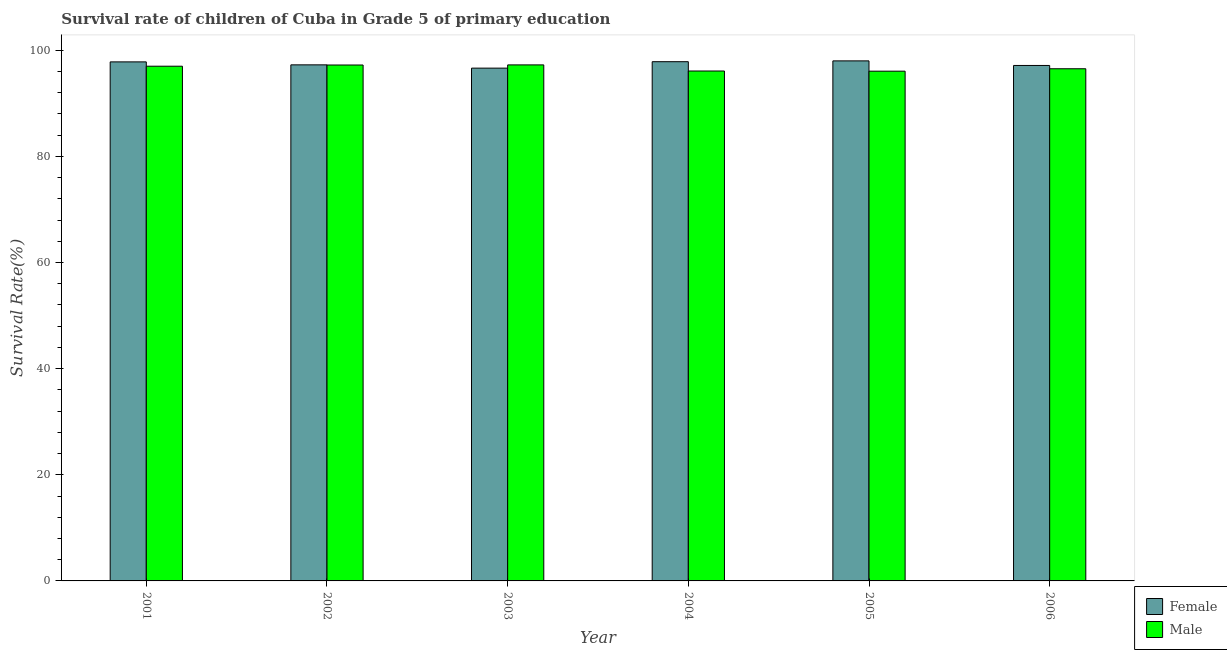How many different coloured bars are there?
Give a very brief answer. 2. Are the number of bars on each tick of the X-axis equal?
Provide a short and direct response. Yes. How many bars are there on the 2nd tick from the left?
Keep it short and to the point. 2. How many bars are there on the 1st tick from the right?
Ensure brevity in your answer.  2. What is the label of the 6th group of bars from the left?
Provide a short and direct response. 2006. In how many cases, is the number of bars for a given year not equal to the number of legend labels?
Your answer should be compact. 0. What is the survival rate of male students in primary education in 2004?
Your answer should be compact. 96.09. Across all years, what is the maximum survival rate of female students in primary education?
Give a very brief answer. 98. Across all years, what is the minimum survival rate of female students in primary education?
Make the answer very short. 96.63. In which year was the survival rate of female students in primary education maximum?
Your response must be concise. 2005. What is the total survival rate of male students in primary education in the graph?
Ensure brevity in your answer.  580.12. What is the difference between the survival rate of female students in primary education in 2001 and that in 2002?
Ensure brevity in your answer.  0.56. What is the difference between the survival rate of female students in primary education in 2001 and the survival rate of male students in primary education in 2006?
Provide a short and direct response. 0.67. What is the average survival rate of male students in primary education per year?
Provide a succinct answer. 96.69. In the year 2003, what is the difference between the survival rate of female students in primary education and survival rate of male students in primary education?
Your response must be concise. 0. In how many years, is the survival rate of male students in primary education greater than 4 %?
Provide a succinct answer. 6. What is the ratio of the survival rate of female students in primary education in 2001 to that in 2003?
Keep it short and to the point. 1.01. Is the survival rate of male students in primary education in 2001 less than that in 2002?
Your response must be concise. Yes. Is the difference between the survival rate of male students in primary education in 2001 and 2006 greater than the difference between the survival rate of female students in primary education in 2001 and 2006?
Provide a succinct answer. No. What is the difference between the highest and the second highest survival rate of female students in primary education?
Your answer should be compact. 0.15. What is the difference between the highest and the lowest survival rate of female students in primary education?
Provide a succinct answer. 1.37. What does the 2nd bar from the right in 2005 represents?
Your answer should be very brief. Female. How many bars are there?
Give a very brief answer. 12. How many years are there in the graph?
Your answer should be very brief. 6. What is the difference between two consecutive major ticks on the Y-axis?
Offer a terse response. 20. Does the graph contain grids?
Provide a succinct answer. No. How are the legend labels stacked?
Your answer should be very brief. Vertical. What is the title of the graph?
Your response must be concise. Survival rate of children of Cuba in Grade 5 of primary education. Does "Under five" appear as one of the legend labels in the graph?
Give a very brief answer. No. What is the label or title of the Y-axis?
Give a very brief answer. Survival Rate(%). What is the Survival Rate(%) of Female in 2001?
Provide a succinct answer. 97.81. What is the Survival Rate(%) of Male in 2001?
Provide a short and direct response. 96.99. What is the Survival Rate(%) of Female in 2002?
Ensure brevity in your answer.  97.25. What is the Survival Rate(%) in Male in 2002?
Your response must be concise. 97.22. What is the Survival Rate(%) in Female in 2003?
Offer a very short reply. 96.63. What is the Survival Rate(%) of Male in 2003?
Your response must be concise. 97.24. What is the Survival Rate(%) in Female in 2004?
Your answer should be compact. 97.84. What is the Survival Rate(%) of Male in 2004?
Give a very brief answer. 96.09. What is the Survival Rate(%) in Female in 2005?
Provide a short and direct response. 98. What is the Survival Rate(%) of Male in 2005?
Offer a very short reply. 96.06. What is the Survival Rate(%) of Female in 2006?
Provide a short and direct response. 97.14. What is the Survival Rate(%) in Male in 2006?
Your answer should be very brief. 96.51. Across all years, what is the maximum Survival Rate(%) in Female?
Keep it short and to the point. 98. Across all years, what is the maximum Survival Rate(%) in Male?
Offer a terse response. 97.24. Across all years, what is the minimum Survival Rate(%) of Female?
Offer a terse response. 96.63. Across all years, what is the minimum Survival Rate(%) in Male?
Your answer should be very brief. 96.06. What is the total Survival Rate(%) in Female in the graph?
Your response must be concise. 584.67. What is the total Survival Rate(%) of Male in the graph?
Ensure brevity in your answer.  580.12. What is the difference between the Survival Rate(%) of Female in 2001 and that in 2002?
Give a very brief answer. 0.56. What is the difference between the Survival Rate(%) in Male in 2001 and that in 2002?
Your response must be concise. -0.23. What is the difference between the Survival Rate(%) in Female in 2001 and that in 2003?
Provide a short and direct response. 1.18. What is the difference between the Survival Rate(%) in Male in 2001 and that in 2003?
Offer a terse response. -0.25. What is the difference between the Survival Rate(%) of Female in 2001 and that in 2004?
Ensure brevity in your answer.  -0.04. What is the difference between the Survival Rate(%) of Male in 2001 and that in 2004?
Offer a very short reply. 0.9. What is the difference between the Survival Rate(%) of Female in 2001 and that in 2005?
Make the answer very short. -0.19. What is the difference between the Survival Rate(%) of Male in 2001 and that in 2005?
Offer a terse response. 0.94. What is the difference between the Survival Rate(%) of Female in 2001 and that in 2006?
Provide a succinct answer. 0.67. What is the difference between the Survival Rate(%) in Male in 2001 and that in 2006?
Your response must be concise. 0.48. What is the difference between the Survival Rate(%) of Female in 2002 and that in 2003?
Keep it short and to the point. 0.62. What is the difference between the Survival Rate(%) of Male in 2002 and that in 2003?
Offer a terse response. -0.02. What is the difference between the Survival Rate(%) in Female in 2002 and that in 2004?
Your answer should be very brief. -0.6. What is the difference between the Survival Rate(%) of Male in 2002 and that in 2004?
Provide a succinct answer. 1.13. What is the difference between the Survival Rate(%) of Female in 2002 and that in 2005?
Make the answer very short. -0.75. What is the difference between the Survival Rate(%) of Male in 2002 and that in 2005?
Offer a terse response. 1.16. What is the difference between the Survival Rate(%) of Female in 2002 and that in 2006?
Make the answer very short. 0.11. What is the difference between the Survival Rate(%) in Male in 2002 and that in 2006?
Your answer should be very brief. 0.71. What is the difference between the Survival Rate(%) in Female in 2003 and that in 2004?
Make the answer very short. -1.21. What is the difference between the Survival Rate(%) of Male in 2003 and that in 2004?
Offer a terse response. 1.15. What is the difference between the Survival Rate(%) of Female in 2003 and that in 2005?
Make the answer very short. -1.37. What is the difference between the Survival Rate(%) in Male in 2003 and that in 2005?
Provide a short and direct response. 1.18. What is the difference between the Survival Rate(%) in Female in 2003 and that in 2006?
Give a very brief answer. -0.5. What is the difference between the Survival Rate(%) in Male in 2003 and that in 2006?
Your answer should be compact. 0.73. What is the difference between the Survival Rate(%) of Female in 2004 and that in 2005?
Make the answer very short. -0.15. What is the difference between the Survival Rate(%) of Male in 2004 and that in 2005?
Your response must be concise. 0.03. What is the difference between the Survival Rate(%) in Female in 2004 and that in 2006?
Keep it short and to the point. 0.71. What is the difference between the Survival Rate(%) in Male in 2004 and that in 2006?
Your answer should be very brief. -0.42. What is the difference between the Survival Rate(%) of Female in 2005 and that in 2006?
Your response must be concise. 0.86. What is the difference between the Survival Rate(%) of Male in 2005 and that in 2006?
Your answer should be very brief. -0.46. What is the difference between the Survival Rate(%) in Female in 2001 and the Survival Rate(%) in Male in 2002?
Your answer should be compact. 0.59. What is the difference between the Survival Rate(%) of Female in 2001 and the Survival Rate(%) of Male in 2003?
Keep it short and to the point. 0.57. What is the difference between the Survival Rate(%) in Female in 2001 and the Survival Rate(%) in Male in 2004?
Your response must be concise. 1.72. What is the difference between the Survival Rate(%) of Female in 2001 and the Survival Rate(%) of Male in 2005?
Make the answer very short. 1.75. What is the difference between the Survival Rate(%) in Female in 2001 and the Survival Rate(%) in Male in 2006?
Provide a succinct answer. 1.29. What is the difference between the Survival Rate(%) in Female in 2002 and the Survival Rate(%) in Male in 2003?
Provide a succinct answer. 0.01. What is the difference between the Survival Rate(%) of Female in 2002 and the Survival Rate(%) of Male in 2004?
Provide a succinct answer. 1.16. What is the difference between the Survival Rate(%) in Female in 2002 and the Survival Rate(%) in Male in 2005?
Provide a succinct answer. 1.19. What is the difference between the Survival Rate(%) in Female in 2002 and the Survival Rate(%) in Male in 2006?
Keep it short and to the point. 0.73. What is the difference between the Survival Rate(%) of Female in 2003 and the Survival Rate(%) of Male in 2004?
Your response must be concise. 0.54. What is the difference between the Survival Rate(%) of Female in 2003 and the Survival Rate(%) of Male in 2005?
Give a very brief answer. 0.57. What is the difference between the Survival Rate(%) of Female in 2003 and the Survival Rate(%) of Male in 2006?
Offer a very short reply. 0.12. What is the difference between the Survival Rate(%) of Female in 2004 and the Survival Rate(%) of Male in 2005?
Keep it short and to the point. 1.79. What is the difference between the Survival Rate(%) in Female in 2004 and the Survival Rate(%) in Male in 2006?
Your response must be concise. 1.33. What is the difference between the Survival Rate(%) of Female in 2005 and the Survival Rate(%) of Male in 2006?
Your answer should be compact. 1.48. What is the average Survival Rate(%) in Female per year?
Give a very brief answer. 97.44. What is the average Survival Rate(%) in Male per year?
Give a very brief answer. 96.69. In the year 2001, what is the difference between the Survival Rate(%) in Female and Survival Rate(%) in Male?
Make the answer very short. 0.81. In the year 2002, what is the difference between the Survival Rate(%) in Female and Survival Rate(%) in Male?
Provide a succinct answer. 0.03. In the year 2003, what is the difference between the Survival Rate(%) of Female and Survival Rate(%) of Male?
Your response must be concise. -0.61. In the year 2004, what is the difference between the Survival Rate(%) of Female and Survival Rate(%) of Male?
Your answer should be compact. 1.75. In the year 2005, what is the difference between the Survival Rate(%) of Female and Survival Rate(%) of Male?
Provide a succinct answer. 1.94. In the year 2006, what is the difference between the Survival Rate(%) of Female and Survival Rate(%) of Male?
Your answer should be very brief. 0.62. What is the ratio of the Survival Rate(%) in Male in 2001 to that in 2002?
Provide a succinct answer. 1. What is the ratio of the Survival Rate(%) in Female in 2001 to that in 2003?
Ensure brevity in your answer.  1.01. What is the ratio of the Survival Rate(%) of Female in 2001 to that in 2004?
Ensure brevity in your answer.  1. What is the ratio of the Survival Rate(%) in Male in 2001 to that in 2004?
Your answer should be compact. 1.01. What is the ratio of the Survival Rate(%) in Male in 2001 to that in 2005?
Keep it short and to the point. 1.01. What is the ratio of the Survival Rate(%) in Male in 2001 to that in 2006?
Provide a succinct answer. 1. What is the ratio of the Survival Rate(%) in Female in 2002 to that in 2003?
Keep it short and to the point. 1.01. What is the ratio of the Survival Rate(%) of Male in 2002 to that in 2004?
Provide a short and direct response. 1.01. What is the ratio of the Survival Rate(%) of Male in 2002 to that in 2005?
Provide a succinct answer. 1.01. What is the ratio of the Survival Rate(%) in Female in 2002 to that in 2006?
Your answer should be compact. 1. What is the ratio of the Survival Rate(%) of Male in 2002 to that in 2006?
Provide a succinct answer. 1.01. What is the ratio of the Survival Rate(%) in Female in 2003 to that in 2004?
Your answer should be compact. 0.99. What is the ratio of the Survival Rate(%) of Female in 2003 to that in 2005?
Your answer should be very brief. 0.99. What is the ratio of the Survival Rate(%) of Male in 2003 to that in 2005?
Keep it short and to the point. 1.01. What is the ratio of the Survival Rate(%) in Female in 2003 to that in 2006?
Ensure brevity in your answer.  0.99. What is the ratio of the Survival Rate(%) in Male in 2003 to that in 2006?
Your response must be concise. 1.01. What is the ratio of the Survival Rate(%) of Female in 2004 to that in 2005?
Your answer should be compact. 1. What is the ratio of the Survival Rate(%) of Male in 2004 to that in 2005?
Provide a succinct answer. 1. What is the ratio of the Survival Rate(%) of Female in 2004 to that in 2006?
Your response must be concise. 1.01. What is the ratio of the Survival Rate(%) in Male in 2004 to that in 2006?
Keep it short and to the point. 1. What is the ratio of the Survival Rate(%) in Female in 2005 to that in 2006?
Your answer should be very brief. 1.01. What is the ratio of the Survival Rate(%) of Male in 2005 to that in 2006?
Provide a short and direct response. 1. What is the difference between the highest and the second highest Survival Rate(%) of Female?
Your response must be concise. 0.15. What is the difference between the highest and the second highest Survival Rate(%) in Male?
Give a very brief answer. 0.02. What is the difference between the highest and the lowest Survival Rate(%) in Female?
Provide a short and direct response. 1.37. What is the difference between the highest and the lowest Survival Rate(%) of Male?
Offer a very short reply. 1.18. 